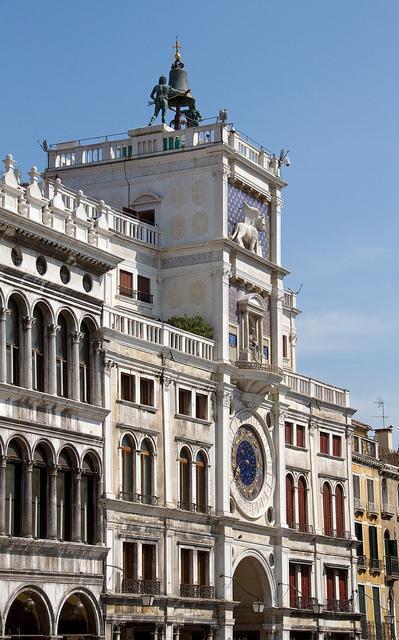How many cars are there?
Give a very brief answer. 0. 